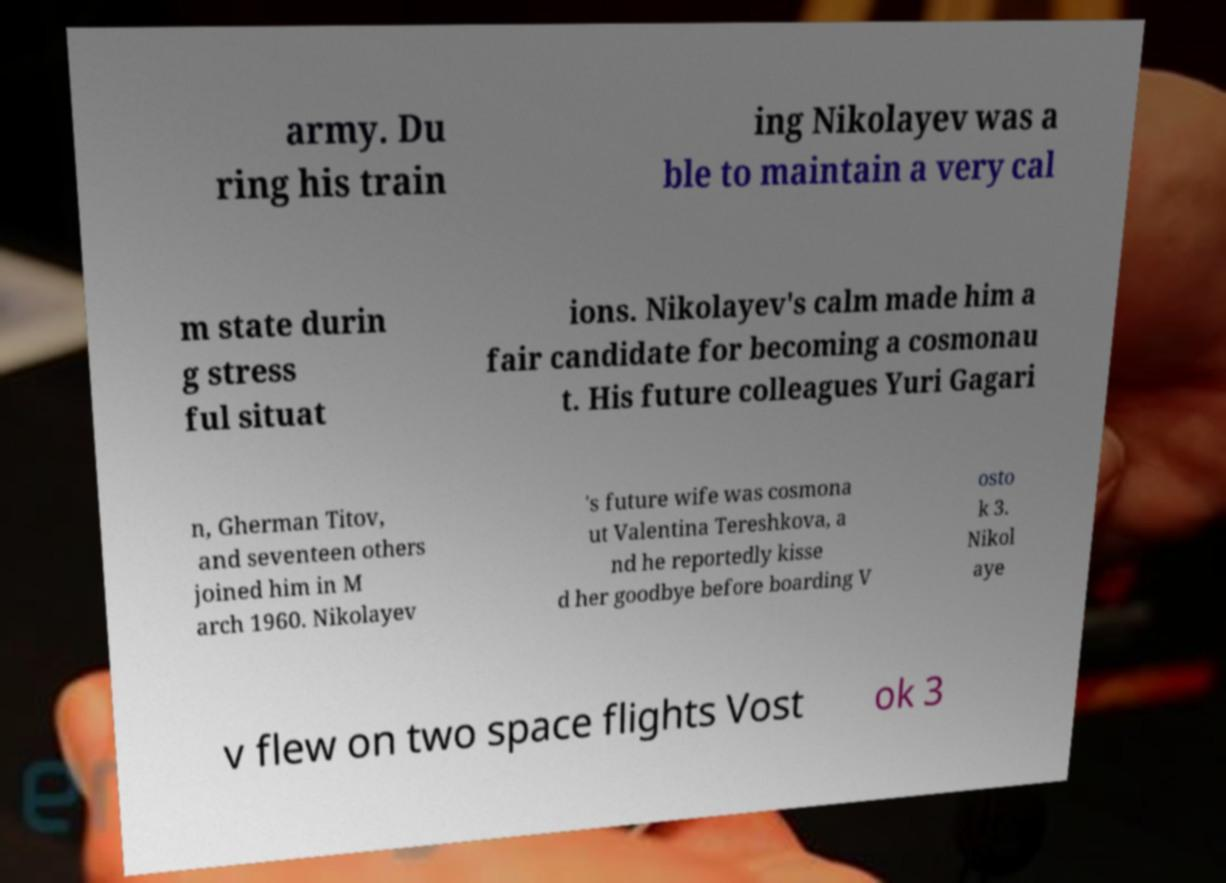Can you accurately transcribe the text from the provided image for me? army. Du ring his train ing Nikolayev was a ble to maintain a very cal m state durin g stress ful situat ions. Nikolayev's calm made him a fair candidate for becoming a cosmonau t. His future colleagues Yuri Gagari n, Gherman Titov, and seventeen others joined him in M arch 1960. Nikolayev 's future wife was cosmona ut Valentina Tereshkova, a nd he reportedly kisse d her goodbye before boarding V osto k 3. Nikol aye v flew on two space flights Vost ok 3 